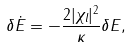<formula> <loc_0><loc_0><loc_500><loc_500>\delta \dot { E } = - \frac { 2 | \chi _ { l } | ^ { 2 } } { \kappa } \delta E ,</formula> 